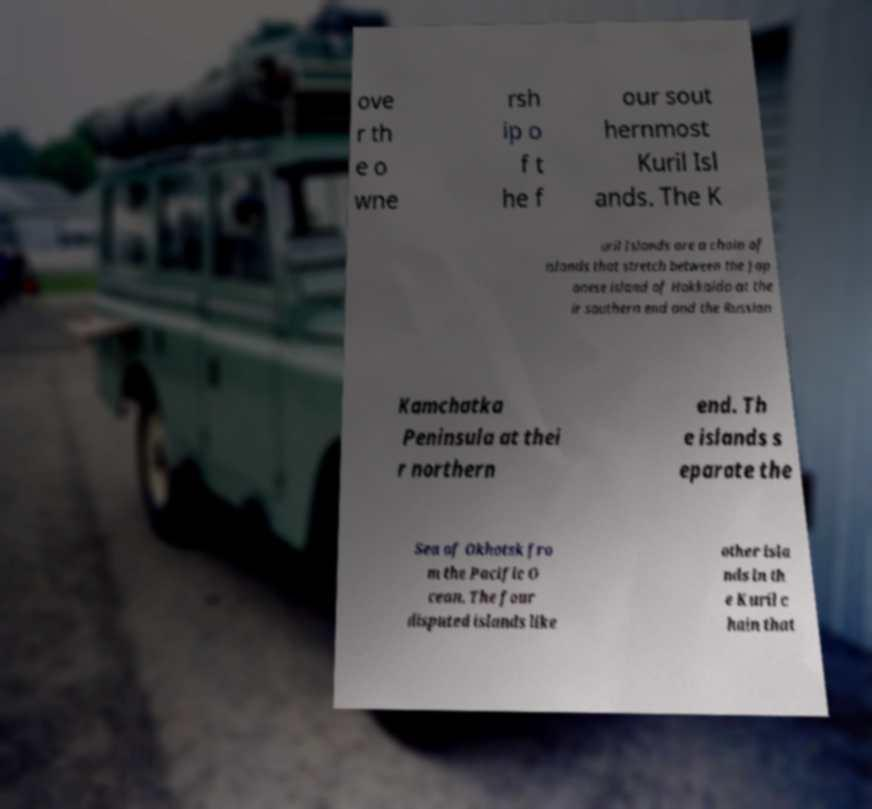For documentation purposes, I need the text within this image transcribed. Could you provide that? ove r th e o wne rsh ip o f t he f our sout hernmost Kuril Isl ands. The K uril Islands are a chain of islands that stretch between the Jap anese island of Hokkaido at the ir southern end and the Russian Kamchatka Peninsula at thei r northern end. Th e islands s eparate the Sea of Okhotsk fro m the Pacific O cean. The four disputed islands like other isla nds in th e Kuril c hain that 